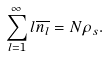<formula> <loc_0><loc_0><loc_500><loc_500>\sum _ { l = 1 } ^ { \infty } l \overline { n _ { l } } = N \rho _ { s } .</formula> 